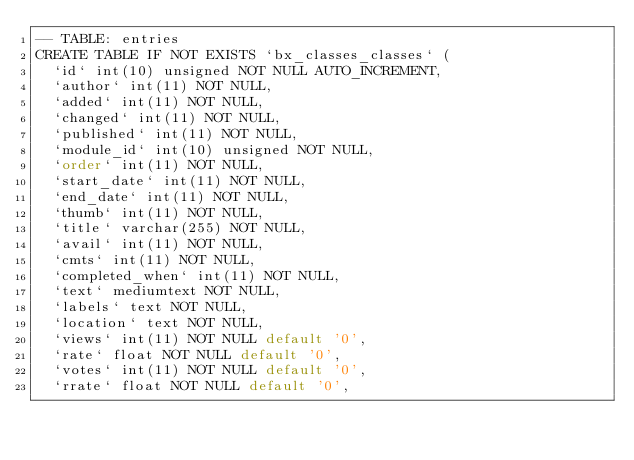<code> <loc_0><loc_0><loc_500><loc_500><_SQL_>-- TABLE: entries
CREATE TABLE IF NOT EXISTS `bx_classes_classes` (
  `id` int(10) unsigned NOT NULL AUTO_INCREMENT,
  `author` int(11) NOT NULL,
  `added` int(11) NOT NULL,
  `changed` int(11) NOT NULL,  
  `published` int(11) NOT NULL,
  `module_id` int(10) unsigned NOT NULL,
  `order` int(11) NOT NULL,
  `start_date` int(11) NOT NULL,
  `end_date` int(11) NOT NULL,
  `thumb` int(11) NOT NULL,
  `title` varchar(255) NOT NULL,
  `avail` int(11) NOT NULL,
  `cmts` int(11) NOT NULL,
  `completed_when` int(11) NOT NULL,
  `text` mediumtext NOT NULL,
  `labels` text NOT NULL,
  `location` text NOT NULL,
  `views` int(11) NOT NULL default '0',
  `rate` float NOT NULL default '0',
  `votes` int(11) NOT NULL default '0',
  `rrate` float NOT NULL default '0',</code> 